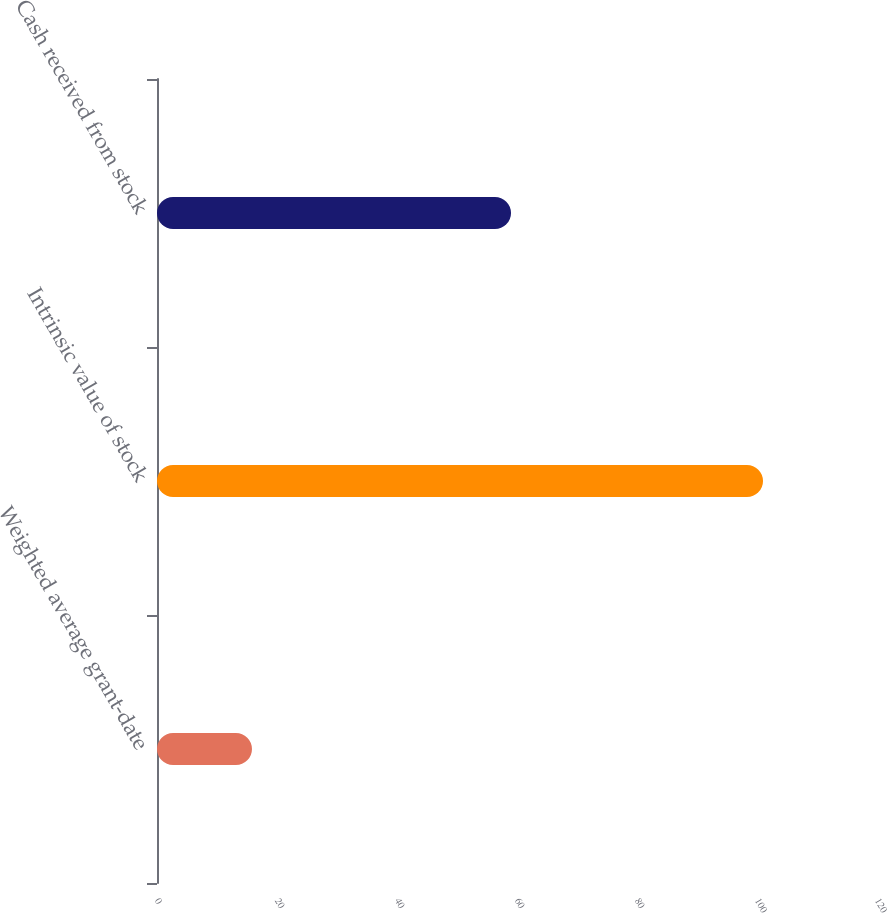Convert chart to OTSL. <chart><loc_0><loc_0><loc_500><loc_500><bar_chart><fcel>Weighted average grant-date<fcel>Intrinsic value of stock<fcel>Cash received from stock<nl><fcel>15.83<fcel>101<fcel>59<nl></chart> 